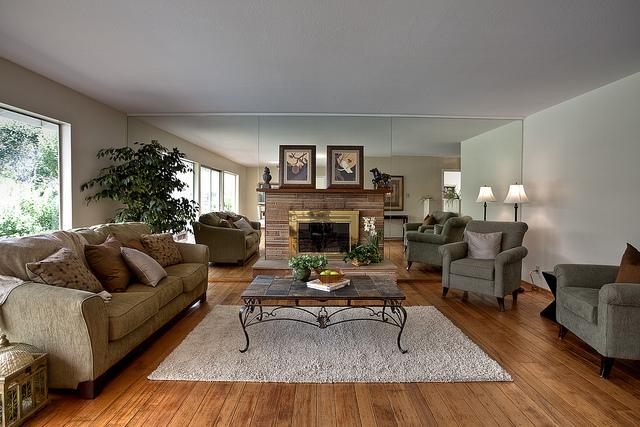What is the gold framed area against the back wall used to hold? Please explain your reasoning. fire. The area is the fireplace. 